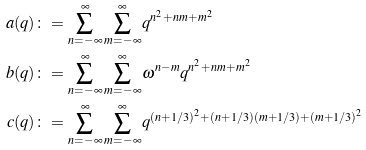<formula> <loc_0><loc_0><loc_500><loc_500>a ( q ) & \colon = \sum _ { n = - \infty } ^ { \infty } \sum _ { m = - \infty } ^ { \infty } q ^ { n ^ { 2 } + n m + m ^ { 2 } } \\ b ( q ) & \colon = \sum _ { n = - \infty } ^ { \infty } \sum _ { m = - \infty } ^ { \infty } \omega ^ { n - m } q ^ { n ^ { 2 } + n m + m ^ { 2 } } \\ c ( q ) & \colon = \sum _ { n = - \infty } ^ { \infty } \sum _ { m = - \infty } ^ { \infty } q ^ { ( n + 1 / 3 ) ^ { 2 } + ( n + 1 / 3 ) ( m + 1 / 3 ) + ( m + 1 / 3 ) ^ { 2 } }</formula> 